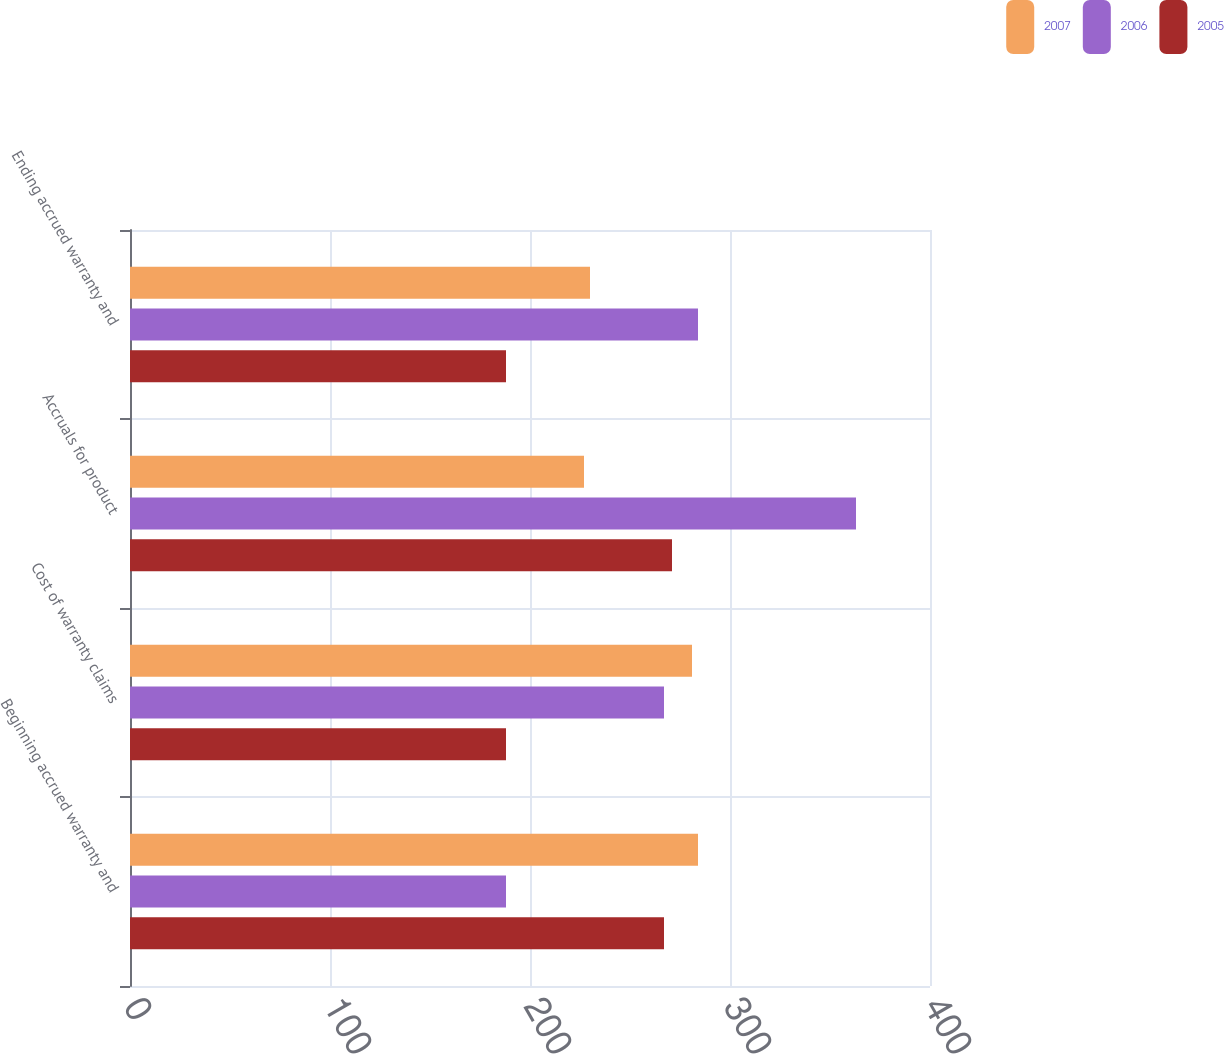Convert chart to OTSL. <chart><loc_0><loc_0><loc_500><loc_500><stacked_bar_chart><ecel><fcel>Beginning accrued warranty and<fcel>Cost of warranty claims<fcel>Accruals for product<fcel>Ending accrued warranty and<nl><fcel>2007<fcel>284<fcel>281<fcel>227<fcel>230<nl><fcel>2006<fcel>188<fcel>267<fcel>363<fcel>284<nl><fcel>2005<fcel>267<fcel>188<fcel>271<fcel>188<nl></chart> 